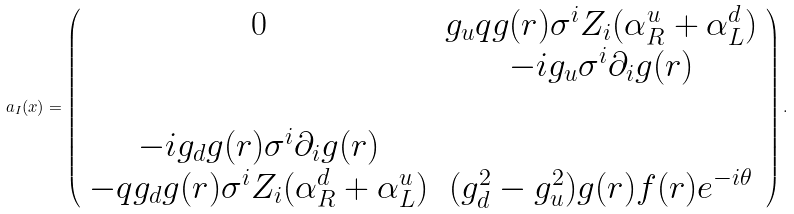Convert formula to latex. <formula><loc_0><loc_0><loc_500><loc_500>a _ { I } ( x ) = \left ( \begin{array} { c c } 0 & g _ { u } q g ( r ) \sigma ^ { i } Z _ { i } ( \alpha _ { R } ^ { u } + \alpha _ { L } ^ { d } ) \\ & - i g _ { u } \sigma ^ { i } \partial _ { i } g ( r ) \\ & \\ - i g _ { d } g ( r ) \sigma ^ { i } \partial _ { i } g ( r ) & \\ - q g _ { d } g ( r ) \sigma ^ { i } Z _ { i } ( \alpha _ { R } ^ { d } + \alpha _ { L } ^ { u } ) & ( g _ { d } ^ { 2 } - g ^ { 2 } _ { u } ) g ( r ) f ( r ) e ^ { - i \theta } \\ \end{array} \right ) .</formula> 